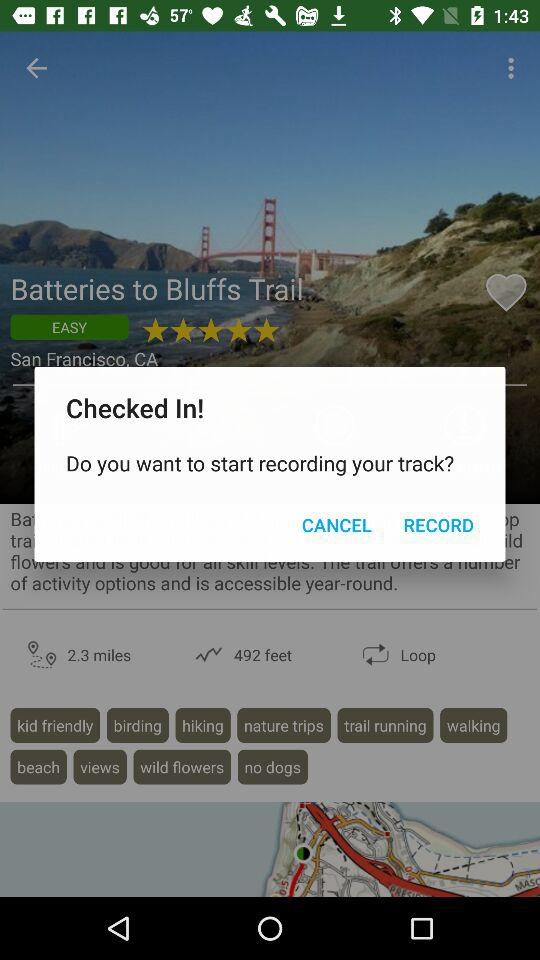Which social media option is given to sign up with? The options are "Facebook" and "Google". 